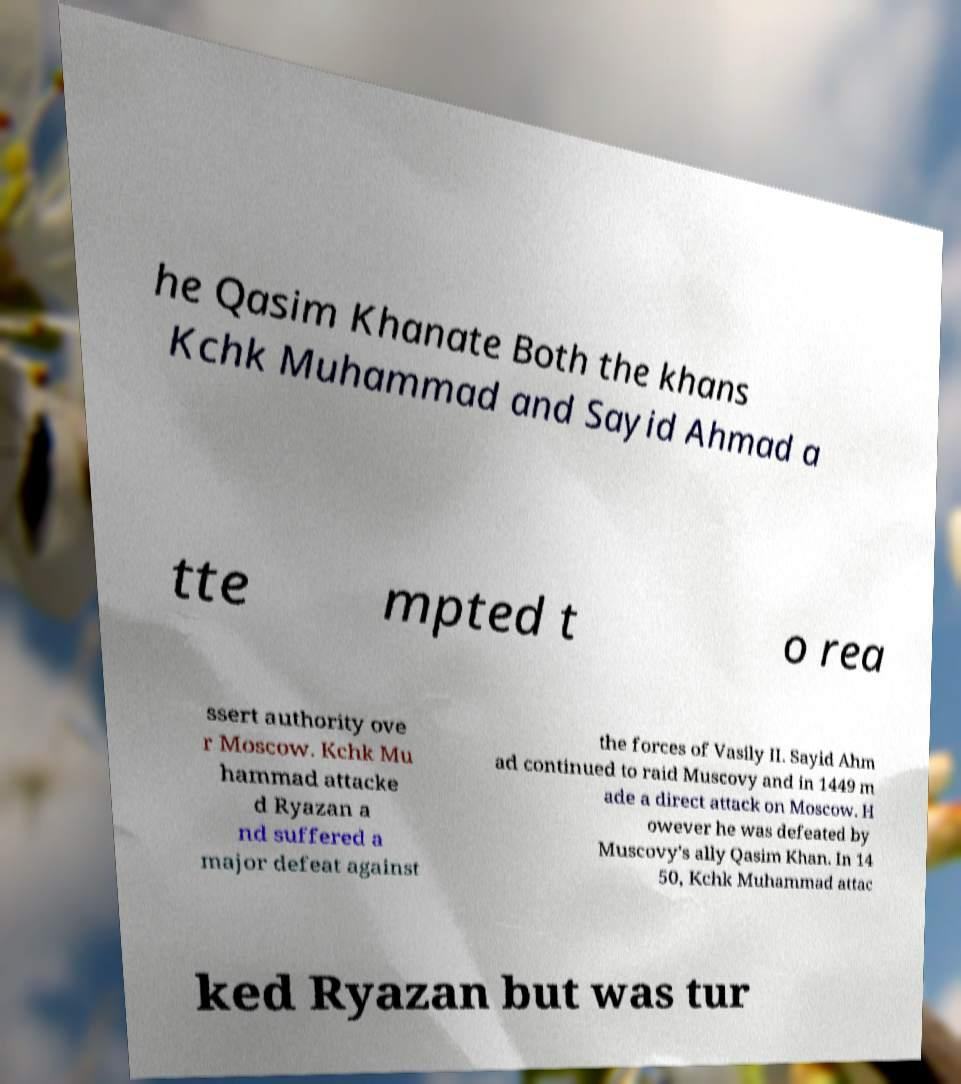Can you accurately transcribe the text from the provided image for me? he Qasim Khanate Both the khans Kchk Muhammad and Sayid Ahmad a tte mpted t o rea ssert authority ove r Moscow. Kchk Mu hammad attacke d Ryazan a nd suffered a major defeat against the forces of Vasily II. Sayid Ahm ad continued to raid Muscovy and in 1449 m ade a direct attack on Moscow. H owever he was defeated by Muscovy's ally Qasim Khan. In 14 50, Kchk Muhammad attac ked Ryazan but was tur 